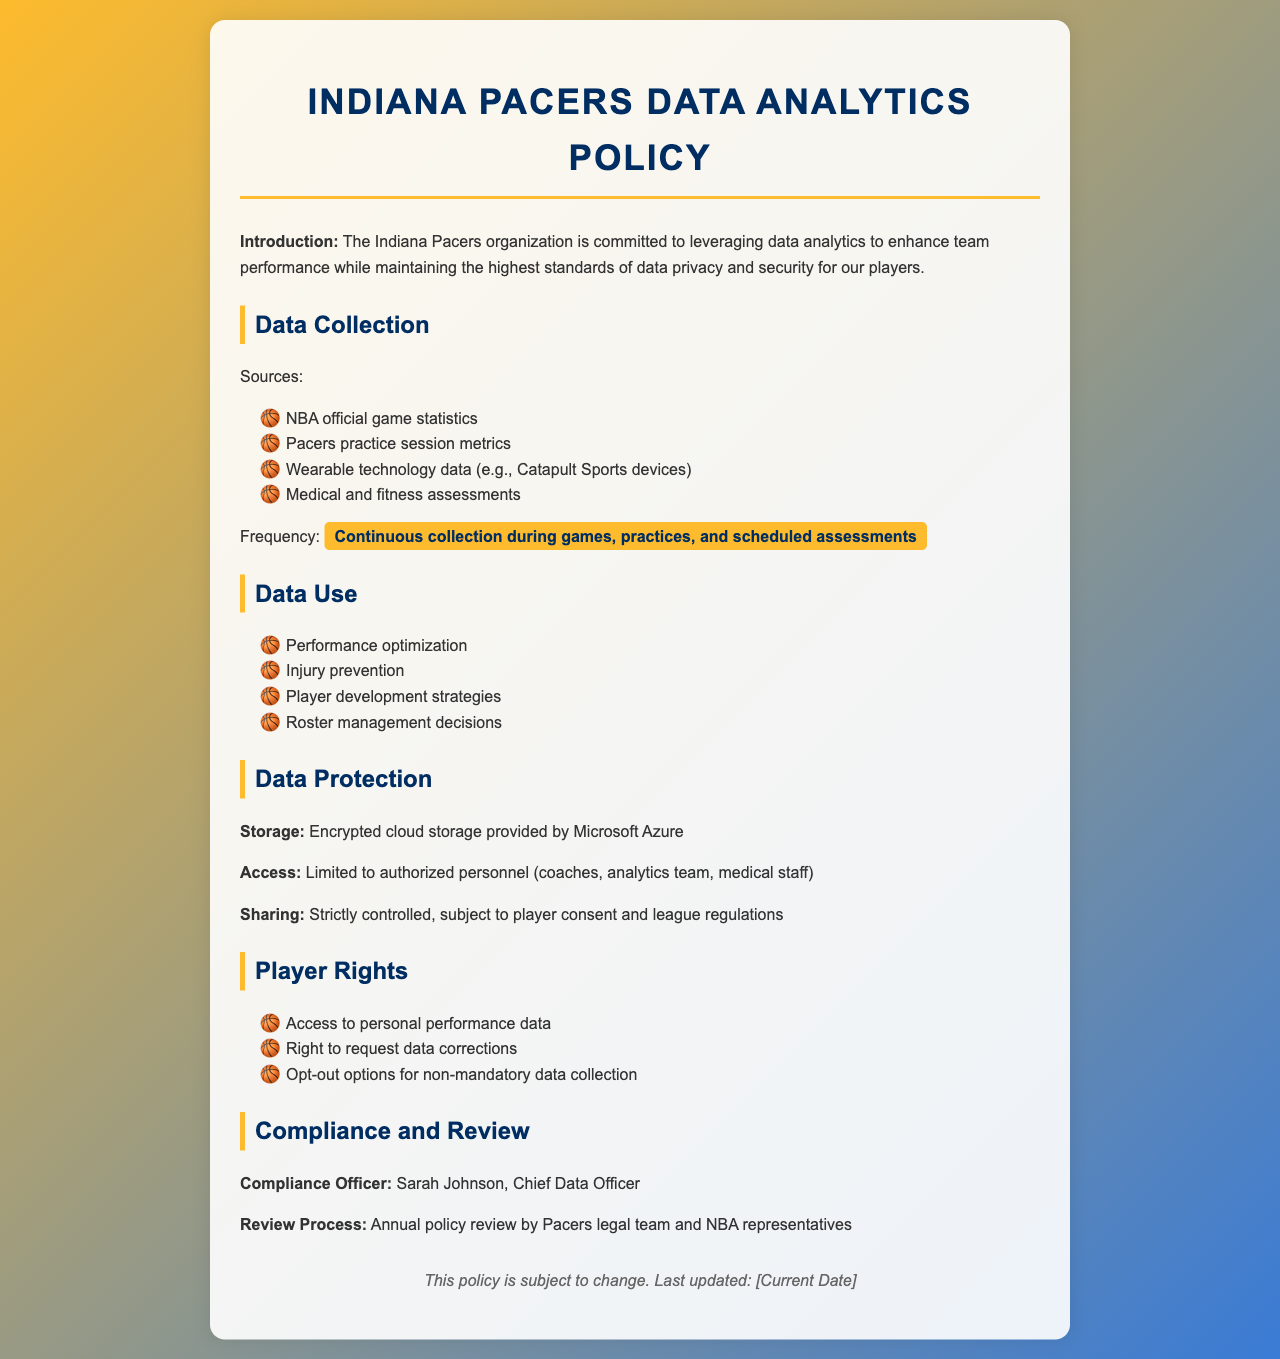what is the name of the compliance officer? The compliance officer is responsible for ensuring that the data analytics policy adheres to applicable laws and regulations, and their name is mentioned in the document.
Answer: Sarah Johnson how often is the data policy reviewed? The review process details how frequently the policy is revisited by the Pacers legal team and NBA representatives, indicating its freshness.
Answer: Annual which type of data is collected using wearable technology? The document lists various sources of data collection, including those associated with technology used during practices and games.
Answer: Wearable technology data what is the method of data storage mentioned? The policy outlines how the collected data will be stored securely, specifying the technology provider used for this purpose.
Answer: Encrypted cloud storage provided by Microsoft Azure who has access to the player performance data? The policy states that access to data is limited and specifies the groups of personnel allowed to view this information.
Answer: Authorized personnel what is one use of the collected data? The document lists several purposes for which the data is utilized, indicating how it contributes to the team’s overall success.
Answer: Performance optimization is player consent required for data sharing? The policy discusses sharing practices which clearly state consent requirements in relation to player privacy and league regulations.
Answer: Yes when was the last update of the policy? The document includes a note indicating that the policy is subject to change and specifies its most recent review date.
Answer: [Current Date] 